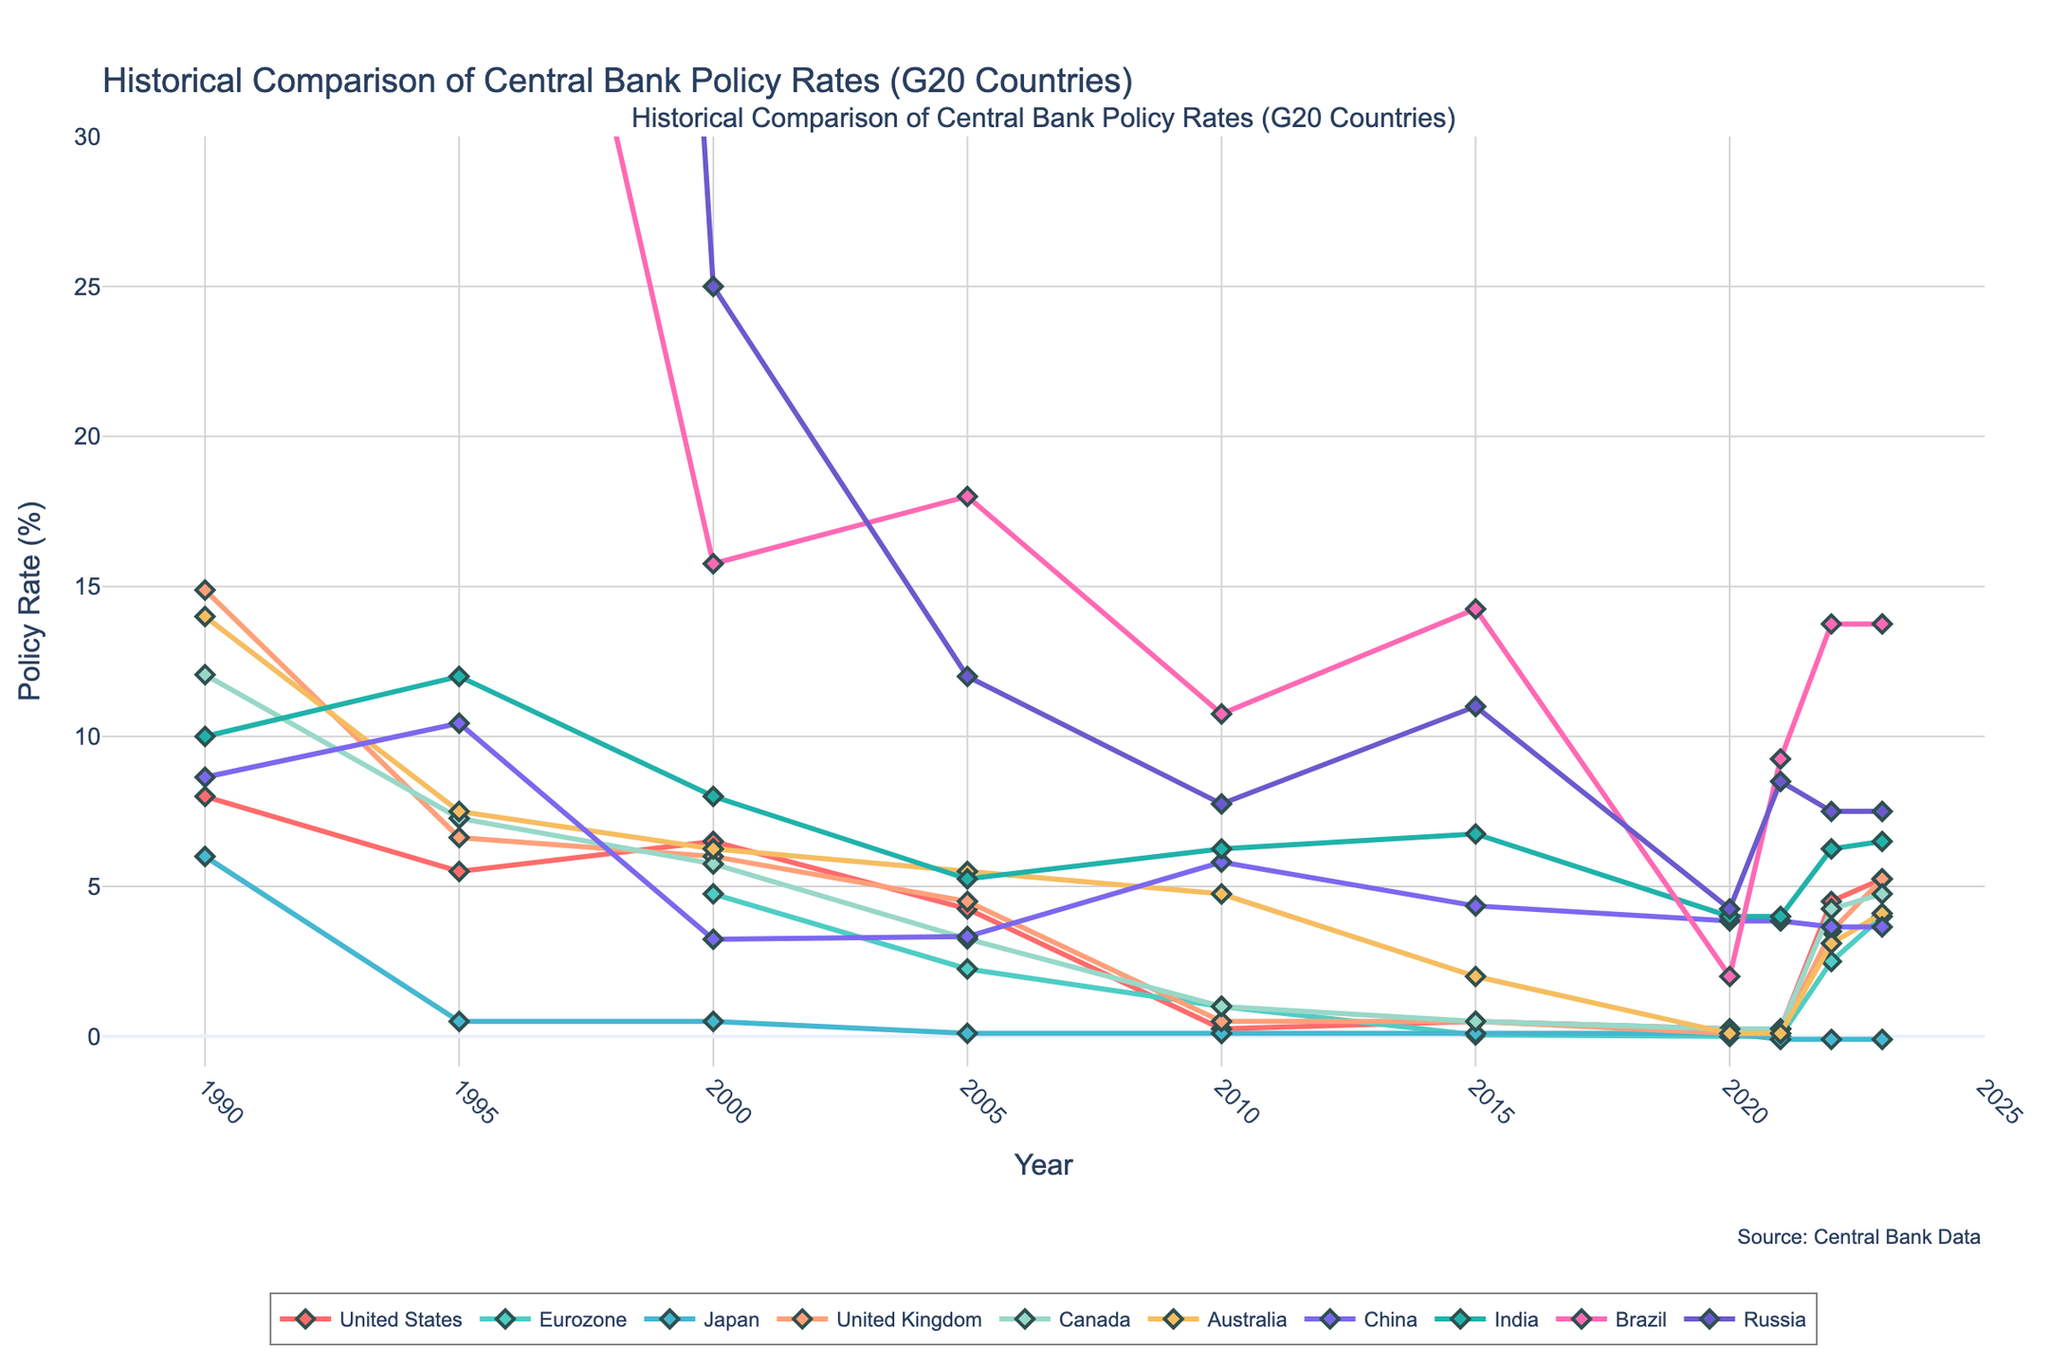what is the difference between the policy rates of the United States and Eurozone in 2000? To find the difference, look at the policy rates of both countries in the year 2000: the United States has a rate of 6.50%, and the Eurozone has a rate of 4.75%. Subtract the Eurozone rate from the US rate: 6.50% - 4.75% = 1.75%.
Answer: 1.75% Which country had the highest policy rate in 1995? In 1995, examine each country’s policy rate: the United States (5.50%), Japan (0.50%), the United Kingdom (6.63%), Canada (7.27%), Australia (7.50%), China (10.44%), India (12.00%), Brazil (53.09%), and Russia (160.00%). Among these, Russia’s policy rate (160.00%) is clearly the highest.
Answer: Russia What was the median policy rate among all countries in 2020? To find the median, first list the policy rates in 2020 in ascending order: 0.00%, 0.10%, 0.10%, 0.25%, 0.25%, 3.85%, 3.85%, 4.00%, 4.25%, 2.00%. As there are 10 values, the median is the average of the 5th and 6th values: (0.25% + 3.85%)/2 = 2.05%.
Answer: 2.05% How did the policy rate in China change from 2005 to 2010? Check China’s policy rates in 2005 and 2010 from the figure: in 2005 it was 3.33%, and in 2010 it was 5.81%. The difference is 5.81% - 3.33% = 2.48%. The policy rate in China increased by 2.48%.
Answer: 2.48% Which country’s policy rate had the least variation from 1990 to 2023? Assess the range of each country’s policy rate over the years. Japan’s rates are 6.00%, 0.50%, 0.10%, 0.10% from 1990 to 2023. Japan’s policy rate stayed within a limited range, showing the least variation.
Answer: Japan In which year did India have the highest policy rate among all the years listed? Refer to India’s policy rates over the years: 1990 (10.00%), 1995 (12.00%), 2000 (8.00%), 2005 (5.25%), 2010 (6.25%), 2015 (6.75%), 2020 (4.00%), 2021 (4.00%), 2022 (6.25%), 2023 (6.50%). The highest rate is in 1995 (12.00%).
Answer: 1995 What was the average policy rate in the Eurozone from 2005 to 2023? To find this, calculate the average of the Eurozone policy rates from 2005 to 2023: 2.25%, 1.00%, 0.05%, 0.00%, 0.00%, 2.50%, 4.00%. Sum these rates and divide by the number of years: (2.25+1.00+0.05+0.00+0.00+2.50+4.00)/7 ≈ 1.26%.
Answer: 1.26% By how much did the policy rate in Brazil decrease from 1995 to 2020? Compare Brazil’s policy rates in 1995 (53.09%) and 2020 (2.00%). The decrease is 53.09% - 2.00% = 51.09%. Thus, Brazil’s policy rate decreased by 51.09%.
Answer: 51.09% 